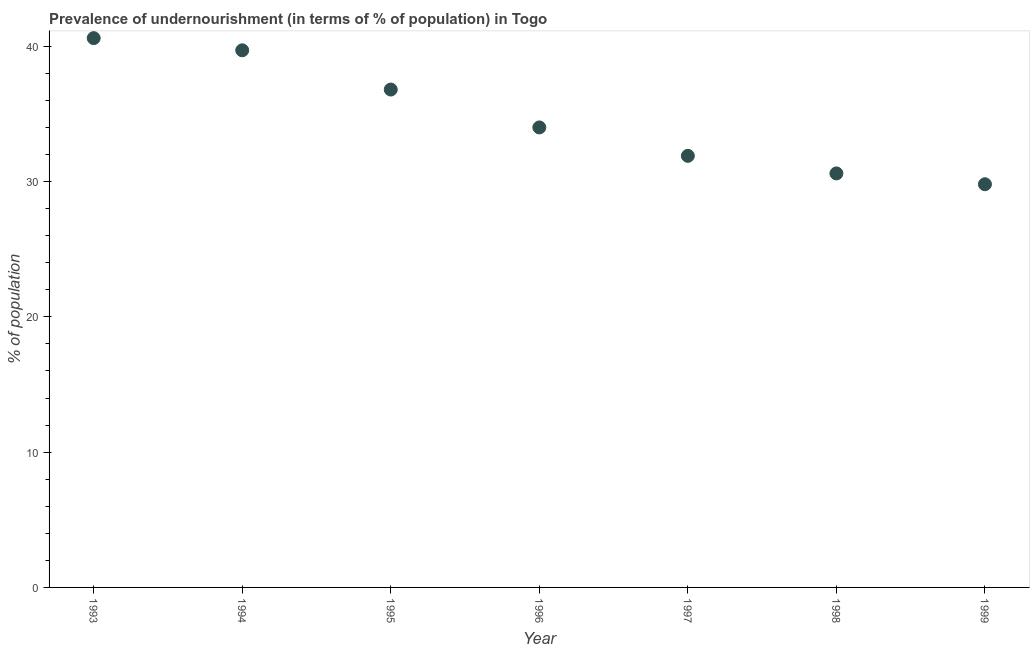What is the percentage of undernourished population in 1996?
Make the answer very short. 34. Across all years, what is the maximum percentage of undernourished population?
Provide a succinct answer. 40.6. Across all years, what is the minimum percentage of undernourished population?
Keep it short and to the point. 29.8. What is the sum of the percentage of undernourished population?
Offer a terse response. 243.4. What is the difference between the percentage of undernourished population in 1993 and 1997?
Your answer should be compact. 8.7. What is the average percentage of undernourished population per year?
Your answer should be compact. 34.77. What is the ratio of the percentage of undernourished population in 1993 to that in 1999?
Your answer should be compact. 1.36. Is the percentage of undernourished population in 1997 less than that in 1999?
Give a very brief answer. No. Is the difference between the percentage of undernourished population in 1997 and 1999 greater than the difference between any two years?
Your response must be concise. No. What is the difference between the highest and the second highest percentage of undernourished population?
Give a very brief answer. 0.9. In how many years, is the percentage of undernourished population greater than the average percentage of undernourished population taken over all years?
Give a very brief answer. 3. Does the percentage of undernourished population monotonically increase over the years?
Give a very brief answer. No. How many dotlines are there?
Your response must be concise. 1. What is the difference between two consecutive major ticks on the Y-axis?
Your answer should be very brief. 10. Are the values on the major ticks of Y-axis written in scientific E-notation?
Provide a succinct answer. No. Does the graph contain any zero values?
Offer a terse response. No. What is the title of the graph?
Provide a short and direct response. Prevalence of undernourishment (in terms of % of population) in Togo. What is the label or title of the X-axis?
Give a very brief answer. Year. What is the label or title of the Y-axis?
Provide a short and direct response. % of population. What is the % of population in 1993?
Your answer should be very brief. 40.6. What is the % of population in 1994?
Provide a short and direct response. 39.7. What is the % of population in 1995?
Provide a short and direct response. 36.8. What is the % of population in 1996?
Your answer should be compact. 34. What is the % of population in 1997?
Your answer should be very brief. 31.9. What is the % of population in 1998?
Make the answer very short. 30.6. What is the % of population in 1999?
Give a very brief answer. 29.8. What is the difference between the % of population in 1993 and 1994?
Keep it short and to the point. 0.9. What is the difference between the % of population in 1993 and 1995?
Give a very brief answer. 3.8. What is the difference between the % of population in 1993 and 1999?
Ensure brevity in your answer.  10.8. What is the difference between the % of population in 1994 and 1996?
Provide a short and direct response. 5.7. What is the difference between the % of population in 1994 and 1998?
Ensure brevity in your answer.  9.1. What is the difference between the % of population in 1994 and 1999?
Give a very brief answer. 9.9. What is the difference between the % of population in 1995 and 1996?
Make the answer very short. 2.8. What is the difference between the % of population in 1995 and 1997?
Ensure brevity in your answer.  4.9. What is the difference between the % of population in 1995 and 1998?
Your answer should be very brief. 6.2. What is the difference between the % of population in 1997 and 1998?
Offer a terse response. 1.3. What is the difference between the % of population in 1998 and 1999?
Ensure brevity in your answer.  0.8. What is the ratio of the % of population in 1993 to that in 1995?
Your answer should be compact. 1.1. What is the ratio of the % of population in 1993 to that in 1996?
Your response must be concise. 1.19. What is the ratio of the % of population in 1993 to that in 1997?
Your answer should be compact. 1.27. What is the ratio of the % of population in 1993 to that in 1998?
Keep it short and to the point. 1.33. What is the ratio of the % of population in 1993 to that in 1999?
Ensure brevity in your answer.  1.36. What is the ratio of the % of population in 1994 to that in 1995?
Give a very brief answer. 1.08. What is the ratio of the % of population in 1994 to that in 1996?
Provide a succinct answer. 1.17. What is the ratio of the % of population in 1994 to that in 1997?
Your answer should be very brief. 1.25. What is the ratio of the % of population in 1994 to that in 1998?
Provide a succinct answer. 1.3. What is the ratio of the % of population in 1994 to that in 1999?
Your answer should be compact. 1.33. What is the ratio of the % of population in 1995 to that in 1996?
Keep it short and to the point. 1.08. What is the ratio of the % of population in 1995 to that in 1997?
Offer a terse response. 1.15. What is the ratio of the % of population in 1995 to that in 1998?
Offer a terse response. 1.2. What is the ratio of the % of population in 1995 to that in 1999?
Provide a short and direct response. 1.24. What is the ratio of the % of population in 1996 to that in 1997?
Your answer should be compact. 1.07. What is the ratio of the % of population in 1996 to that in 1998?
Offer a very short reply. 1.11. What is the ratio of the % of population in 1996 to that in 1999?
Offer a very short reply. 1.14. What is the ratio of the % of population in 1997 to that in 1998?
Offer a terse response. 1.04. What is the ratio of the % of population in 1997 to that in 1999?
Your answer should be very brief. 1.07. 